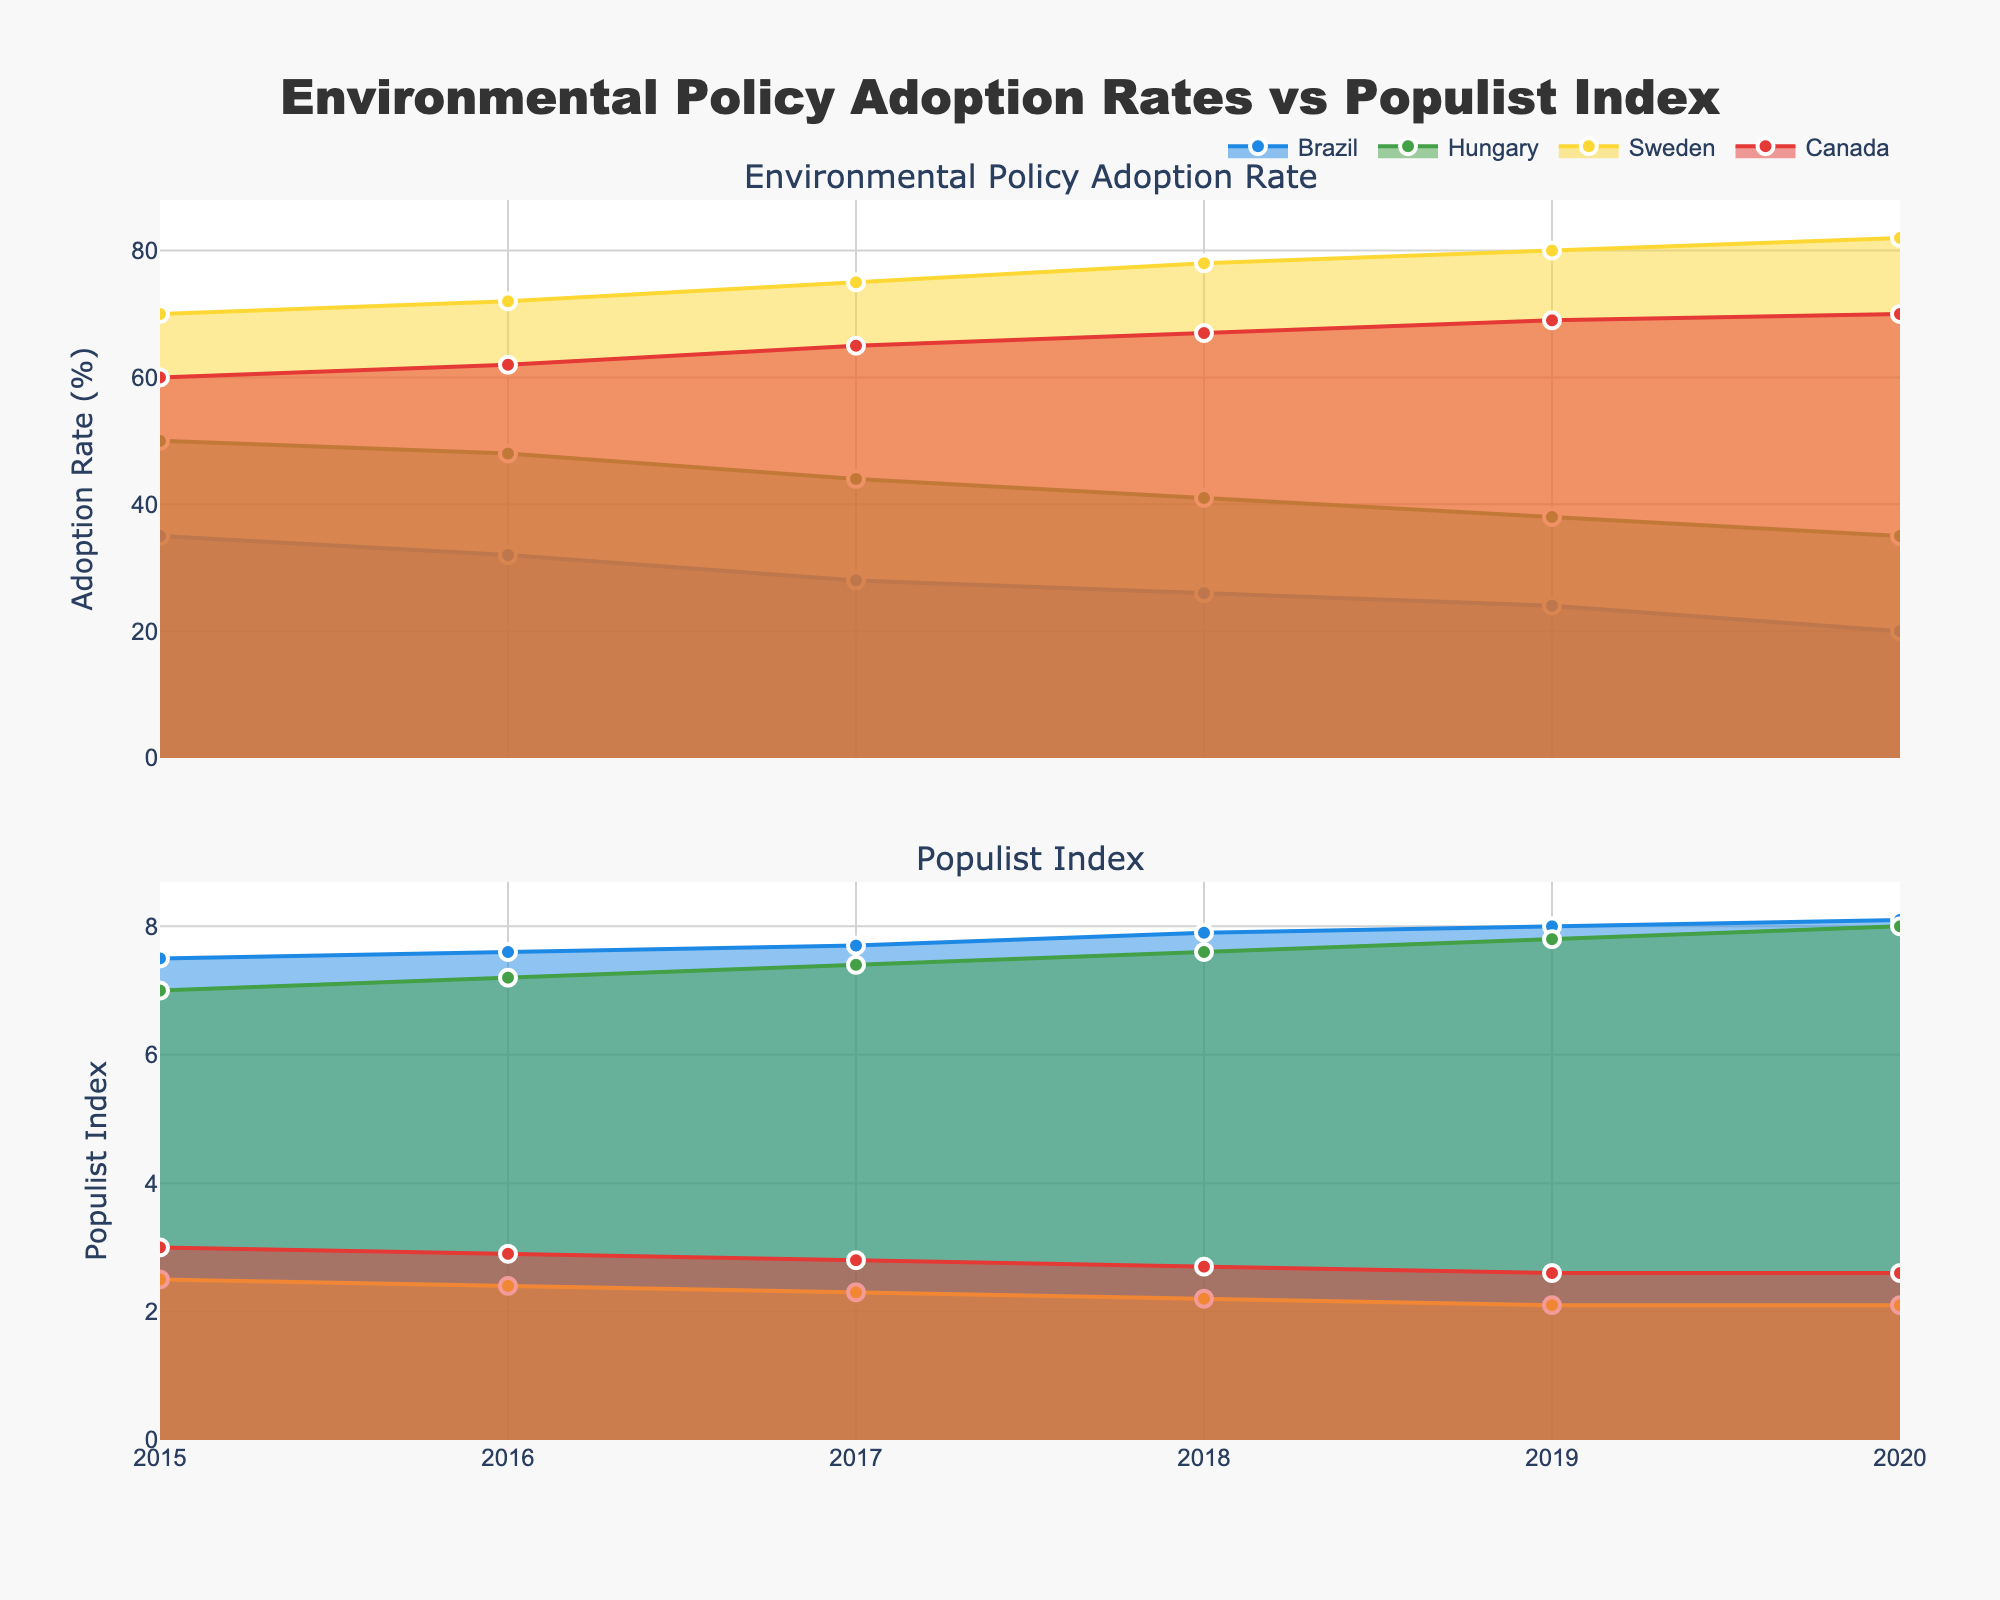What is the title of the figure? The title is usually placed at the top of the figure and is meant to summarize the visual data. In this case, it's given in the plot code.
Answer: "Environmental Policy Adoption Rates vs Populist Index" How does the Environmental Policy Adoption Rate in Brazil change from 2015 to 2020? To answer this, observe the area chart for Brazil's "Environmental Policy Adoption Rate" from 2015 to 2020. Note the starting and ending points, as well as the overall trend. Brazil's rate starts at 35% in 2015 and decreases progressively, reaching 20% in 2020.
Answer: It decreases from 35% to 20% Which country had the highest Environmental Policy Adoption Rate in 2020, and what was the rate? Look for the peak values of the area charts for Environmental Policy Adoption Rates specifically in 2020. The highest rate in 2020 corresponds to Sweden, which is at 82%.
Answer: Sweden, 82% What is the difference in the Populist Index for Hungary from 2015 to 2020? Check the Populist Index area chart for Hungary, note the value in 2015 and the value in 2020. Hungary's Populist Index starts at 7.0 in 2015 and goes up to 8.0 in 2020. The difference is found by subtracting the former from the latter: 8.0 - 7.0.
Answer: 1.0 Compare the trends of Environmental Policy Adoption Rates between Canada and Sweden from 2015 to 2020. Which country shows a consistent increase? Monitor the trends in the area charts for Canada and Sweden. Sweden's rate consistently increases each year from 70% to 82%. Canada's rate also increases but more gradually from 60% to 70%. Hence, both countries show increases, but Sweden's is more consistent and substantial.
Answer: Sweden By how much did Brazil's Populist Index increase from 2015 to 2020? Look at the Brazil Populist Index data points for 2015 and 2020 in the area chart. Brazil's Index starts at 7.5 in 2015 and reaches 8.1 in 2020. Calculate the increase by subtracting the 2015 value from the 2020 value: 8.1 - 7.5.
Answer: 0.6 Which country had the lowest Environmental Policy Adoption Rate in 2020? Identify the minimum value among the 2020 data points for Environmental Policy Adoption Rates across all countries. The lowest rate in 2020 is for Brazil, which stands at 20%.
Answer: Brazil By how much did Hungary's Environmental Policy Adoption Rate decline from 2015 to 2020? Look at Hungary's Environmental Policy Adoption Rate for 2015 and 2020. It starts at 50% in 2015 and drops to 35% in 2020. Calculate the decline by subtracting the 2020 value from the 2015 value: 50% - 35%.
Answer: 15% What is the average Environmental Policy Adoption Rate for Canada between 2015 and 2020? Sum the Environmental Policy Adoption Rates for Canada from 2015 to 2020 and divide by the number of years. The rates are 60, 62, 65, 67, 69, and 70. Adding these gives 393. Dividing by 6 gives: 393/6.
Answer: 65.5 Which country shows a decrease in both the Populist Index and Environmental Policy Adoption Rate? Check if there is a single country whose both the Populist Index and Environmental Policy Adoption Rate decrease. Inspection indicates that Canada and Sweden show consistent rises, while Brazil and Hungary show only increases in the Populist Index but decreases in Environmental Policy Adoption Rate. Hence, no country shows both decreases.
Answer: None 